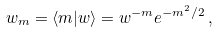Convert formula to latex. <formula><loc_0><loc_0><loc_500><loc_500>w _ { m } = \langle m | w \rangle = w ^ { - m } e ^ { - m ^ { 2 } / 2 } \, ,</formula> 